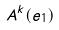<formula> <loc_0><loc_0><loc_500><loc_500>A ^ { k } ( e _ { 1 } )</formula> 